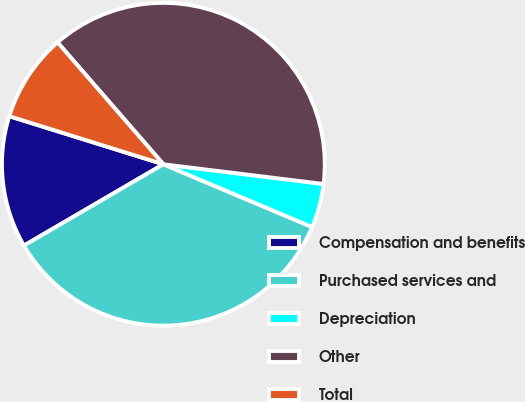Convert chart. <chart><loc_0><loc_0><loc_500><loc_500><pie_chart><fcel>Compensation and benefits<fcel>Purchased services and<fcel>Depreciation<fcel>Other<fcel>Total<nl><fcel>13.22%<fcel>35.24%<fcel>4.41%<fcel>38.33%<fcel>8.81%<nl></chart> 